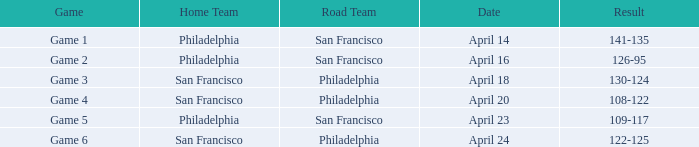Which games had Philadelphia as home team? Game 1, Game 2, Game 5. 